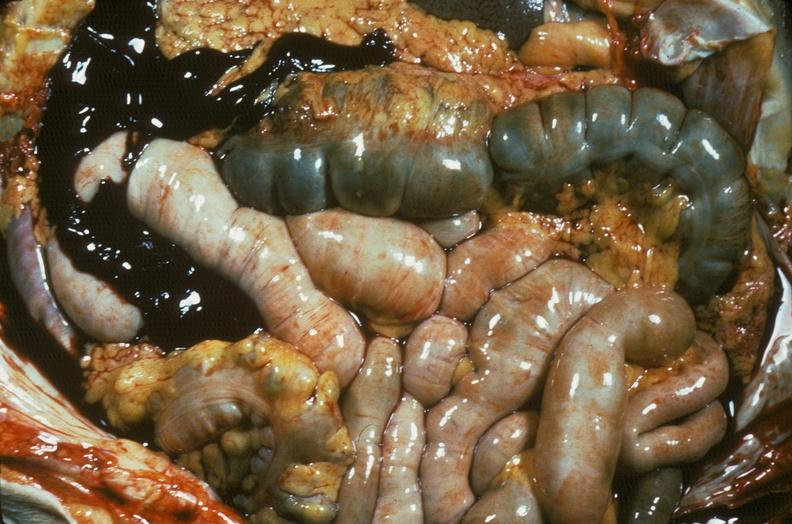s abdomen present?
Answer the question using a single word or phrase. Yes 